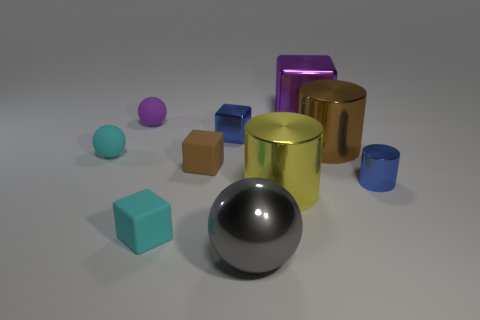Subtract all tiny balls. How many balls are left? 1 Subtract all yellow cylinders. How many cylinders are left? 2 Subtract all cubes. How many objects are left? 6 Subtract 1 spheres. How many spheres are left? 2 Add 6 large yellow shiny cylinders. How many large yellow shiny cylinders are left? 7 Add 7 small purple balls. How many small purple balls exist? 8 Subtract 0 purple cylinders. How many objects are left? 10 Subtract all purple cubes. Subtract all yellow cylinders. How many cubes are left? 3 Subtract all large yellow cylinders. Subtract all small purple rubber spheres. How many objects are left? 8 